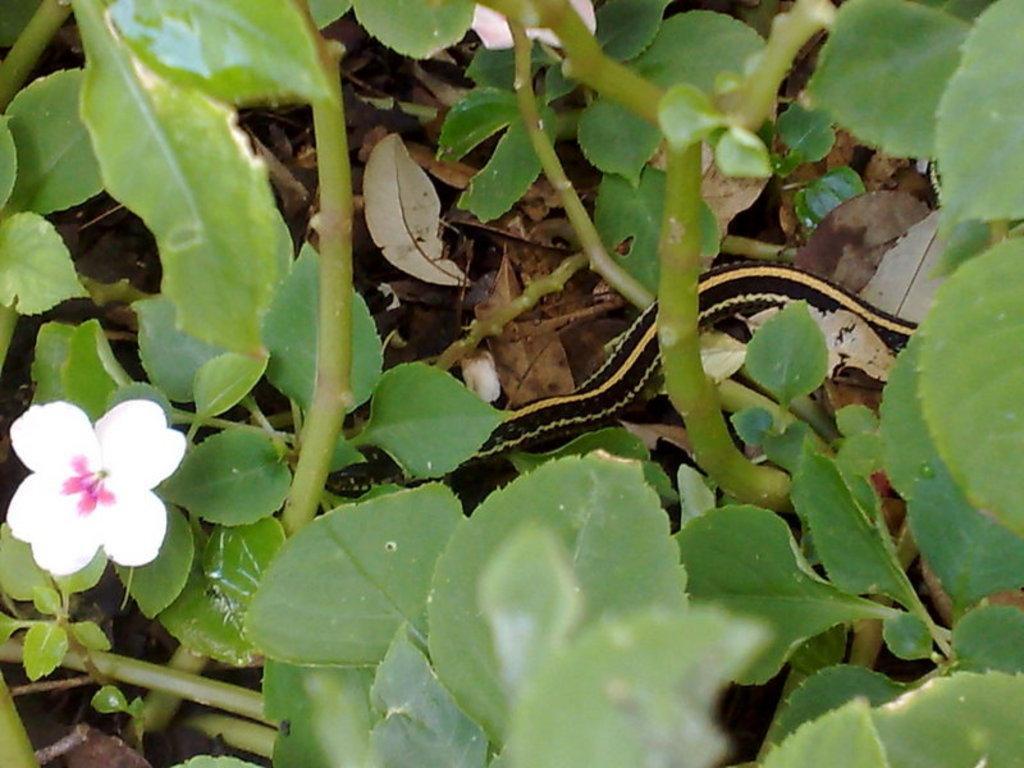How would you summarize this image in a sentence or two? In this image at the bottom left hand corner we can see there is a flower, and in the middle we can see there is a snake. 